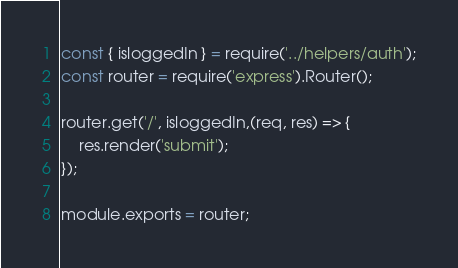Convert code to text. <code><loc_0><loc_0><loc_500><loc_500><_JavaScript_>const { isloggedIn } = require('../helpers/auth');
const router = require('express').Router();

router.get('/', isloggedIn,(req, res) => {
    res.render('submit');
});

module.exports = router;</code> 